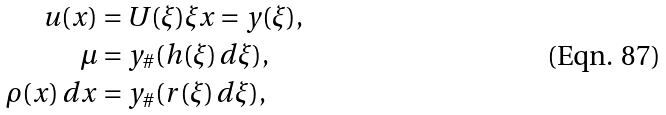<formula> <loc_0><loc_0><loc_500><loc_500>u ( x ) & = U ( \xi ) \xi x = y ( \xi ) , \\ \mu & = y _ { \# } ( h ( \xi ) \, d \xi ) , \\ \rho ( x ) \, d x & = y _ { \# } ( r ( \xi ) \, d \xi ) ,</formula> 